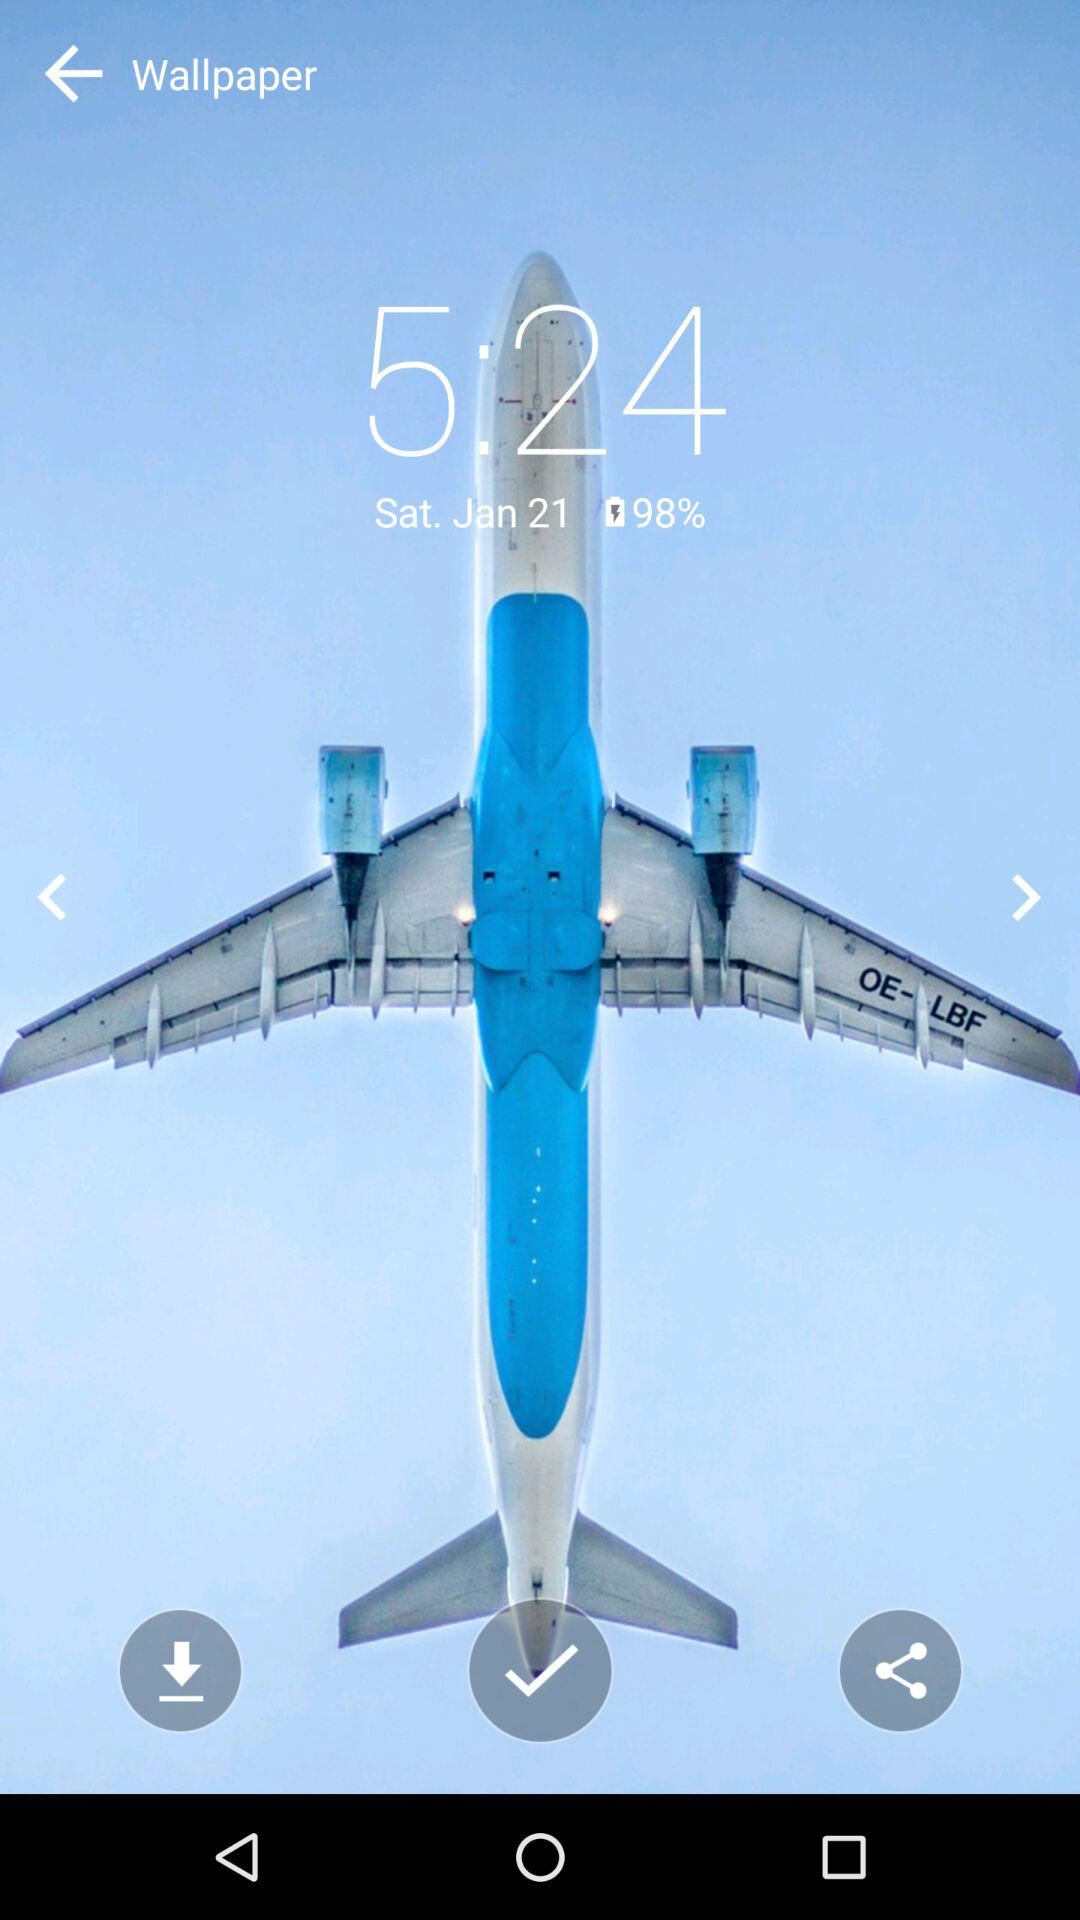What is the day on January 21? The day is Saturday. 